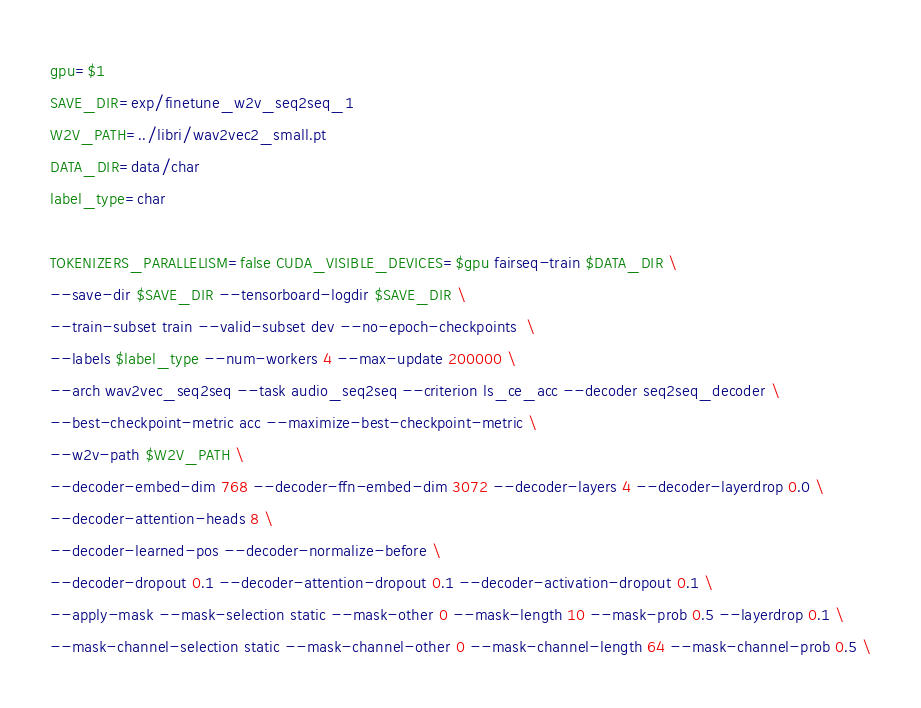<code> <loc_0><loc_0><loc_500><loc_500><_Bash_>gpu=$1
SAVE_DIR=exp/finetune_w2v_seq2seq_1
W2V_PATH=../libri/wav2vec2_small.pt
DATA_DIR=data/char
label_type=char

TOKENIZERS_PARALLELISM=false CUDA_VISIBLE_DEVICES=$gpu fairseq-train $DATA_DIR \
--save-dir $SAVE_DIR --tensorboard-logdir $SAVE_DIR \
--train-subset train --valid-subset dev --no-epoch-checkpoints  \
--labels $label_type --num-workers 4 --max-update 200000 \
--arch wav2vec_seq2seq --task audio_seq2seq --criterion ls_ce_acc --decoder seq2seq_decoder \
--best-checkpoint-metric acc --maximize-best-checkpoint-metric \
--w2v-path $W2V_PATH \
--decoder-embed-dim 768 --decoder-ffn-embed-dim 3072 --decoder-layers 4 --decoder-layerdrop 0.0 \
--decoder-attention-heads 8 \
--decoder-learned-pos --decoder-normalize-before \
--decoder-dropout 0.1 --decoder-attention-dropout 0.1 --decoder-activation-dropout 0.1 \
--apply-mask --mask-selection static --mask-other 0 --mask-length 10 --mask-prob 0.5 --layerdrop 0.1 \
--mask-channel-selection static --mask-channel-other 0 --mask-channel-length 64 --mask-channel-prob 0.5 \</code> 